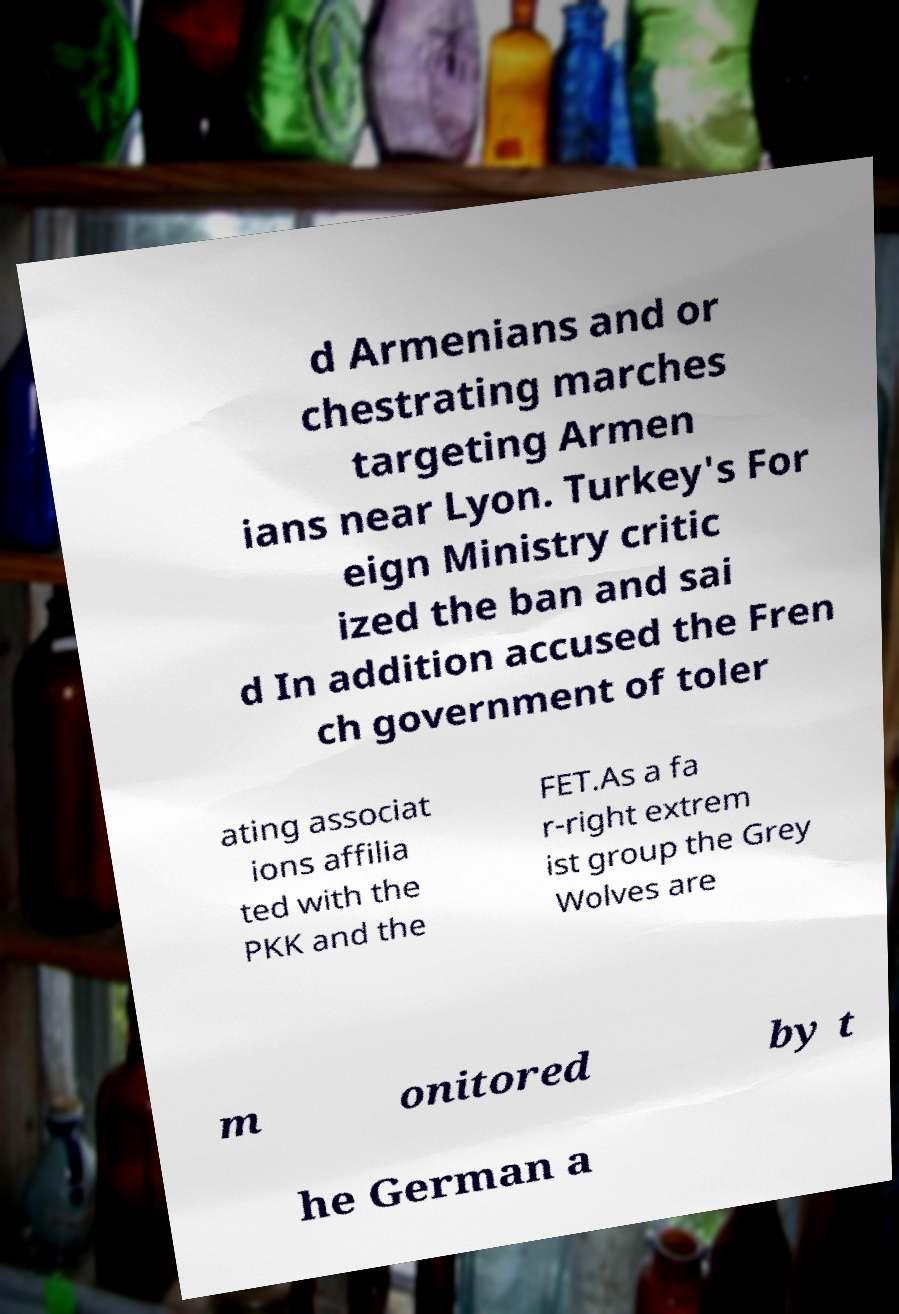Can you read and provide the text displayed in the image?This photo seems to have some interesting text. Can you extract and type it out for me? d Armenians and or chestrating marches targeting Armen ians near Lyon. Turkey's For eign Ministry critic ized the ban and sai d In addition accused the Fren ch government of toler ating associat ions affilia ted with the PKK and the FET.As a fa r-right extrem ist group the Grey Wolves are m onitored by t he German a 